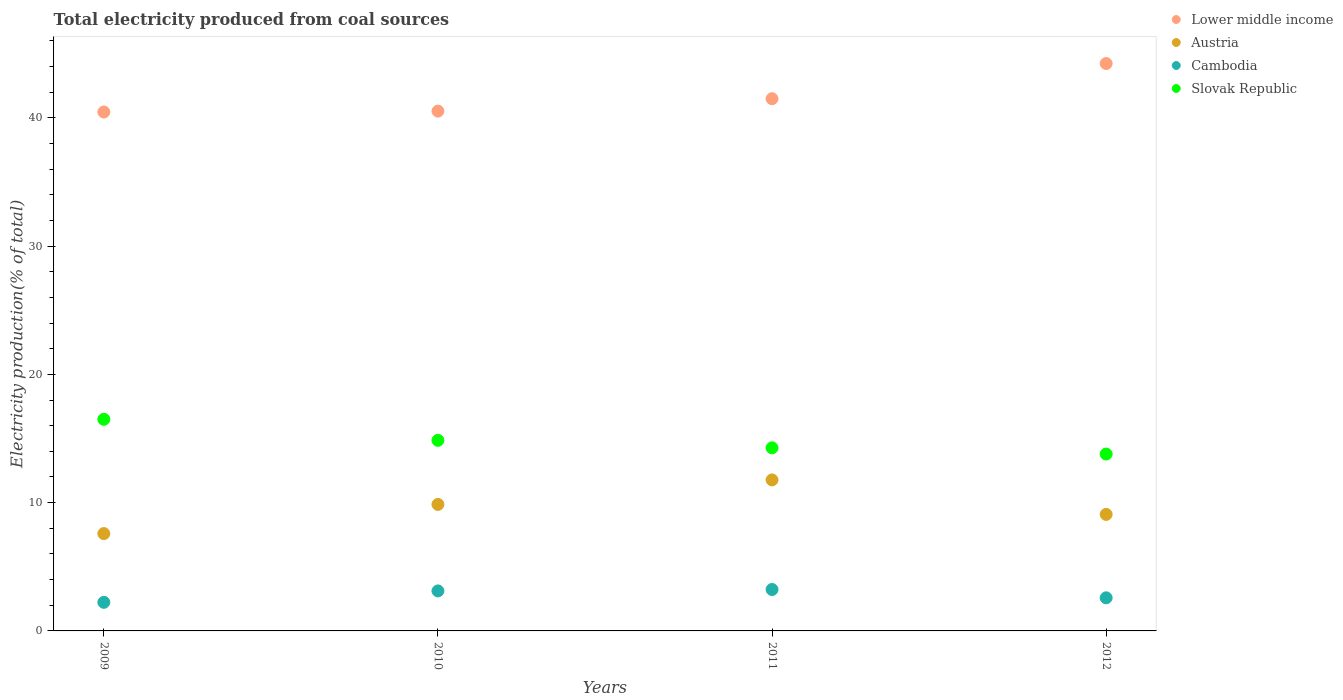How many different coloured dotlines are there?
Provide a short and direct response. 4. Is the number of dotlines equal to the number of legend labels?
Make the answer very short. Yes. What is the total electricity produced in Austria in 2011?
Your response must be concise. 11.77. Across all years, what is the maximum total electricity produced in Austria?
Keep it short and to the point. 11.77. Across all years, what is the minimum total electricity produced in Cambodia?
Provide a short and direct response. 2.23. What is the total total electricity produced in Cambodia in the graph?
Your answer should be compact. 11.16. What is the difference between the total electricity produced in Lower middle income in 2010 and that in 2012?
Offer a terse response. -3.71. What is the difference between the total electricity produced in Lower middle income in 2010 and the total electricity produced in Austria in 2012?
Offer a very short reply. 31.44. What is the average total electricity produced in Lower middle income per year?
Keep it short and to the point. 41.67. In the year 2011, what is the difference between the total electricity produced in Slovak Republic and total electricity produced in Austria?
Provide a succinct answer. 2.5. What is the ratio of the total electricity produced in Cambodia in 2010 to that in 2012?
Your answer should be compact. 1.21. Is the difference between the total electricity produced in Slovak Republic in 2009 and 2012 greater than the difference between the total electricity produced in Austria in 2009 and 2012?
Provide a succinct answer. Yes. What is the difference between the highest and the second highest total electricity produced in Austria?
Your answer should be very brief. 1.91. What is the difference between the highest and the lowest total electricity produced in Slovak Republic?
Give a very brief answer. 2.71. Is it the case that in every year, the sum of the total electricity produced in Cambodia and total electricity produced in Lower middle income  is greater than the sum of total electricity produced in Austria and total electricity produced in Slovak Republic?
Make the answer very short. Yes. Is the total electricity produced in Austria strictly greater than the total electricity produced in Cambodia over the years?
Your answer should be very brief. Yes. Is the total electricity produced in Austria strictly less than the total electricity produced in Slovak Republic over the years?
Provide a succinct answer. Yes. How many years are there in the graph?
Your response must be concise. 4. What is the difference between two consecutive major ticks on the Y-axis?
Offer a very short reply. 10. How are the legend labels stacked?
Make the answer very short. Vertical. What is the title of the graph?
Your answer should be very brief. Total electricity produced from coal sources. Does "Paraguay" appear as one of the legend labels in the graph?
Your answer should be very brief. No. What is the label or title of the X-axis?
Provide a succinct answer. Years. What is the label or title of the Y-axis?
Your answer should be very brief. Electricity production(% of total). What is the Electricity production(% of total) of Lower middle income in 2009?
Make the answer very short. 40.45. What is the Electricity production(% of total) of Austria in 2009?
Make the answer very short. 7.59. What is the Electricity production(% of total) of Cambodia in 2009?
Give a very brief answer. 2.23. What is the Electricity production(% of total) in Slovak Republic in 2009?
Your answer should be compact. 16.5. What is the Electricity production(% of total) of Lower middle income in 2010?
Provide a succinct answer. 40.52. What is the Electricity production(% of total) of Austria in 2010?
Your response must be concise. 9.86. What is the Electricity production(% of total) in Cambodia in 2010?
Offer a terse response. 3.12. What is the Electricity production(% of total) in Slovak Republic in 2010?
Provide a short and direct response. 14.86. What is the Electricity production(% of total) of Lower middle income in 2011?
Make the answer very short. 41.49. What is the Electricity production(% of total) of Austria in 2011?
Offer a very short reply. 11.77. What is the Electricity production(% of total) in Cambodia in 2011?
Ensure brevity in your answer.  3.23. What is the Electricity production(% of total) in Slovak Republic in 2011?
Provide a short and direct response. 14.27. What is the Electricity production(% of total) of Lower middle income in 2012?
Make the answer very short. 44.23. What is the Electricity production(% of total) in Austria in 2012?
Offer a very short reply. 9.08. What is the Electricity production(% of total) in Cambodia in 2012?
Offer a terse response. 2.58. What is the Electricity production(% of total) of Slovak Republic in 2012?
Your answer should be very brief. 13.79. Across all years, what is the maximum Electricity production(% of total) in Lower middle income?
Offer a very short reply. 44.23. Across all years, what is the maximum Electricity production(% of total) of Austria?
Ensure brevity in your answer.  11.77. Across all years, what is the maximum Electricity production(% of total) in Cambodia?
Your answer should be very brief. 3.23. Across all years, what is the maximum Electricity production(% of total) of Slovak Republic?
Your response must be concise. 16.5. Across all years, what is the minimum Electricity production(% of total) in Lower middle income?
Give a very brief answer. 40.45. Across all years, what is the minimum Electricity production(% of total) in Austria?
Give a very brief answer. 7.59. Across all years, what is the minimum Electricity production(% of total) in Cambodia?
Provide a succinct answer. 2.23. Across all years, what is the minimum Electricity production(% of total) of Slovak Republic?
Ensure brevity in your answer.  13.79. What is the total Electricity production(% of total) in Lower middle income in the graph?
Offer a terse response. 166.7. What is the total Electricity production(% of total) in Austria in the graph?
Make the answer very short. 38.31. What is the total Electricity production(% of total) in Cambodia in the graph?
Your answer should be very brief. 11.16. What is the total Electricity production(% of total) of Slovak Republic in the graph?
Your answer should be very brief. 59.42. What is the difference between the Electricity production(% of total) of Lower middle income in 2009 and that in 2010?
Keep it short and to the point. -0.07. What is the difference between the Electricity production(% of total) of Austria in 2009 and that in 2010?
Your answer should be very brief. -2.27. What is the difference between the Electricity production(% of total) of Cambodia in 2009 and that in 2010?
Your answer should be very brief. -0.89. What is the difference between the Electricity production(% of total) of Slovak Republic in 2009 and that in 2010?
Provide a succinct answer. 1.64. What is the difference between the Electricity production(% of total) in Lower middle income in 2009 and that in 2011?
Your response must be concise. -1.04. What is the difference between the Electricity production(% of total) in Austria in 2009 and that in 2011?
Provide a short and direct response. -4.18. What is the difference between the Electricity production(% of total) in Cambodia in 2009 and that in 2011?
Provide a short and direct response. -1. What is the difference between the Electricity production(% of total) of Slovak Republic in 2009 and that in 2011?
Provide a succinct answer. 2.22. What is the difference between the Electricity production(% of total) in Lower middle income in 2009 and that in 2012?
Your answer should be very brief. -3.78. What is the difference between the Electricity production(% of total) in Austria in 2009 and that in 2012?
Keep it short and to the point. -1.5. What is the difference between the Electricity production(% of total) in Cambodia in 2009 and that in 2012?
Your answer should be compact. -0.35. What is the difference between the Electricity production(% of total) of Slovak Republic in 2009 and that in 2012?
Your answer should be compact. 2.71. What is the difference between the Electricity production(% of total) in Lower middle income in 2010 and that in 2011?
Make the answer very short. -0.97. What is the difference between the Electricity production(% of total) of Austria in 2010 and that in 2011?
Make the answer very short. -1.91. What is the difference between the Electricity production(% of total) of Cambodia in 2010 and that in 2011?
Your answer should be very brief. -0.11. What is the difference between the Electricity production(% of total) in Slovak Republic in 2010 and that in 2011?
Provide a short and direct response. 0.58. What is the difference between the Electricity production(% of total) of Lower middle income in 2010 and that in 2012?
Provide a short and direct response. -3.71. What is the difference between the Electricity production(% of total) of Austria in 2010 and that in 2012?
Your answer should be compact. 0.78. What is the difference between the Electricity production(% of total) in Cambodia in 2010 and that in 2012?
Give a very brief answer. 0.54. What is the difference between the Electricity production(% of total) of Slovak Republic in 2010 and that in 2012?
Your response must be concise. 1.07. What is the difference between the Electricity production(% of total) of Lower middle income in 2011 and that in 2012?
Make the answer very short. -2.74. What is the difference between the Electricity production(% of total) in Austria in 2011 and that in 2012?
Provide a succinct answer. 2.69. What is the difference between the Electricity production(% of total) in Cambodia in 2011 and that in 2012?
Make the answer very short. 0.65. What is the difference between the Electricity production(% of total) in Slovak Republic in 2011 and that in 2012?
Offer a terse response. 0.49. What is the difference between the Electricity production(% of total) of Lower middle income in 2009 and the Electricity production(% of total) of Austria in 2010?
Make the answer very short. 30.59. What is the difference between the Electricity production(% of total) of Lower middle income in 2009 and the Electricity production(% of total) of Cambodia in 2010?
Make the answer very short. 37.33. What is the difference between the Electricity production(% of total) in Lower middle income in 2009 and the Electricity production(% of total) in Slovak Republic in 2010?
Your answer should be compact. 25.6. What is the difference between the Electricity production(% of total) of Austria in 2009 and the Electricity production(% of total) of Cambodia in 2010?
Give a very brief answer. 4.47. What is the difference between the Electricity production(% of total) in Austria in 2009 and the Electricity production(% of total) in Slovak Republic in 2010?
Your answer should be compact. -7.27. What is the difference between the Electricity production(% of total) of Cambodia in 2009 and the Electricity production(% of total) of Slovak Republic in 2010?
Provide a short and direct response. -12.63. What is the difference between the Electricity production(% of total) in Lower middle income in 2009 and the Electricity production(% of total) in Austria in 2011?
Make the answer very short. 28.68. What is the difference between the Electricity production(% of total) of Lower middle income in 2009 and the Electricity production(% of total) of Cambodia in 2011?
Your answer should be very brief. 37.22. What is the difference between the Electricity production(% of total) of Lower middle income in 2009 and the Electricity production(% of total) of Slovak Republic in 2011?
Ensure brevity in your answer.  26.18. What is the difference between the Electricity production(% of total) of Austria in 2009 and the Electricity production(% of total) of Cambodia in 2011?
Make the answer very short. 4.36. What is the difference between the Electricity production(% of total) in Austria in 2009 and the Electricity production(% of total) in Slovak Republic in 2011?
Give a very brief answer. -6.69. What is the difference between the Electricity production(% of total) in Cambodia in 2009 and the Electricity production(% of total) in Slovak Republic in 2011?
Keep it short and to the point. -12.05. What is the difference between the Electricity production(% of total) of Lower middle income in 2009 and the Electricity production(% of total) of Austria in 2012?
Your answer should be very brief. 31.37. What is the difference between the Electricity production(% of total) of Lower middle income in 2009 and the Electricity production(% of total) of Cambodia in 2012?
Your answer should be very brief. 37.87. What is the difference between the Electricity production(% of total) of Lower middle income in 2009 and the Electricity production(% of total) of Slovak Republic in 2012?
Your answer should be compact. 26.66. What is the difference between the Electricity production(% of total) of Austria in 2009 and the Electricity production(% of total) of Cambodia in 2012?
Keep it short and to the point. 5.01. What is the difference between the Electricity production(% of total) of Austria in 2009 and the Electricity production(% of total) of Slovak Republic in 2012?
Make the answer very short. -6.2. What is the difference between the Electricity production(% of total) in Cambodia in 2009 and the Electricity production(% of total) in Slovak Republic in 2012?
Your answer should be compact. -11.56. What is the difference between the Electricity production(% of total) of Lower middle income in 2010 and the Electricity production(% of total) of Austria in 2011?
Give a very brief answer. 28.75. What is the difference between the Electricity production(% of total) of Lower middle income in 2010 and the Electricity production(% of total) of Cambodia in 2011?
Provide a succinct answer. 37.29. What is the difference between the Electricity production(% of total) in Lower middle income in 2010 and the Electricity production(% of total) in Slovak Republic in 2011?
Your answer should be compact. 26.25. What is the difference between the Electricity production(% of total) in Austria in 2010 and the Electricity production(% of total) in Cambodia in 2011?
Your answer should be very brief. 6.63. What is the difference between the Electricity production(% of total) in Austria in 2010 and the Electricity production(% of total) in Slovak Republic in 2011?
Offer a very short reply. -4.41. What is the difference between the Electricity production(% of total) in Cambodia in 2010 and the Electricity production(% of total) in Slovak Republic in 2011?
Make the answer very short. -11.16. What is the difference between the Electricity production(% of total) of Lower middle income in 2010 and the Electricity production(% of total) of Austria in 2012?
Give a very brief answer. 31.44. What is the difference between the Electricity production(% of total) in Lower middle income in 2010 and the Electricity production(% of total) in Cambodia in 2012?
Your answer should be compact. 37.94. What is the difference between the Electricity production(% of total) of Lower middle income in 2010 and the Electricity production(% of total) of Slovak Republic in 2012?
Make the answer very short. 26.73. What is the difference between the Electricity production(% of total) of Austria in 2010 and the Electricity production(% of total) of Cambodia in 2012?
Provide a short and direct response. 7.28. What is the difference between the Electricity production(% of total) of Austria in 2010 and the Electricity production(% of total) of Slovak Republic in 2012?
Your answer should be very brief. -3.93. What is the difference between the Electricity production(% of total) of Cambodia in 2010 and the Electricity production(% of total) of Slovak Republic in 2012?
Provide a short and direct response. -10.67. What is the difference between the Electricity production(% of total) in Lower middle income in 2011 and the Electricity production(% of total) in Austria in 2012?
Offer a very short reply. 32.41. What is the difference between the Electricity production(% of total) of Lower middle income in 2011 and the Electricity production(% of total) of Cambodia in 2012?
Offer a terse response. 38.91. What is the difference between the Electricity production(% of total) in Lower middle income in 2011 and the Electricity production(% of total) in Slovak Republic in 2012?
Offer a terse response. 27.7. What is the difference between the Electricity production(% of total) in Austria in 2011 and the Electricity production(% of total) in Cambodia in 2012?
Keep it short and to the point. 9.19. What is the difference between the Electricity production(% of total) in Austria in 2011 and the Electricity production(% of total) in Slovak Republic in 2012?
Offer a terse response. -2.02. What is the difference between the Electricity production(% of total) of Cambodia in 2011 and the Electricity production(% of total) of Slovak Republic in 2012?
Ensure brevity in your answer.  -10.56. What is the average Electricity production(% of total) of Lower middle income per year?
Make the answer very short. 41.67. What is the average Electricity production(% of total) of Austria per year?
Your answer should be very brief. 9.58. What is the average Electricity production(% of total) in Cambodia per year?
Offer a very short reply. 2.79. What is the average Electricity production(% of total) of Slovak Republic per year?
Provide a short and direct response. 14.85. In the year 2009, what is the difference between the Electricity production(% of total) in Lower middle income and Electricity production(% of total) in Austria?
Offer a very short reply. 32.87. In the year 2009, what is the difference between the Electricity production(% of total) in Lower middle income and Electricity production(% of total) in Cambodia?
Your answer should be very brief. 38.22. In the year 2009, what is the difference between the Electricity production(% of total) of Lower middle income and Electricity production(% of total) of Slovak Republic?
Provide a short and direct response. 23.96. In the year 2009, what is the difference between the Electricity production(% of total) of Austria and Electricity production(% of total) of Cambodia?
Keep it short and to the point. 5.36. In the year 2009, what is the difference between the Electricity production(% of total) of Austria and Electricity production(% of total) of Slovak Republic?
Your answer should be very brief. -8.91. In the year 2009, what is the difference between the Electricity production(% of total) in Cambodia and Electricity production(% of total) in Slovak Republic?
Provide a short and direct response. -14.27. In the year 2010, what is the difference between the Electricity production(% of total) in Lower middle income and Electricity production(% of total) in Austria?
Ensure brevity in your answer.  30.66. In the year 2010, what is the difference between the Electricity production(% of total) of Lower middle income and Electricity production(% of total) of Cambodia?
Keep it short and to the point. 37.4. In the year 2010, what is the difference between the Electricity production(% of total) in Lower middle income and Electricity production(% of total) in Slovak Republic?
Offer a terse response. 25.67. In the year 2010, what is the difference between the Electricity production(% of total) in Austria and Electricity production(% of total) in Cambodia?
Provide a succinct answer. 6.74. In the year 2010, what is the difference between the Electricity production(% of total) in Austria and Electricity production(% of total) in Slovak Republic?
Your answer should be very brief. -4.99. In the year 2010, what is the difference between the Electricity production(% of total) of Cambodia and Electricity production(% of total) of Slovak Republic?
Provide a succinct answer. -11.74. In the year 2011, what is the difference between the Electricity production(% of total) of Lower middle income and Electricity production(% of total) of Austria?
Give a very brief answer. 29.72. In the year 2011, what is the difference between the Electricity production(% of total) of Lower middle income and Electricity production(% of total) of Cambodia?
Ensure brevity in your answer.  38.26. In the year 2011, what is the difference between the Electricity production(% of total) of Lower middle income and Electricity production(% of total) of Slovak Republic?
Offer a very short reply. 27.21. In the year 2011, what is the difference between the Electricity production(% of total) in Austria and Electricity production(% of total) in Cambodia?
Offer a very short reply. 8.54. In the year 2011, what is the difference between the Electricity production(% of total) in Austria and Electricity production(% of total) in Slovak Republic?
Your response must be concise. -2.5. In the year 2011, what is the difference between the Electricity production(% of total) of Cambodia and Electricity production(% of total) of Slovak Republic?
Your answer should be very brief. -11.05. In the year 2012, what is the difference between the Electricity production(% of total) of Lower middle income and Electricity production(% of total) of Austria?
Offer a very short reply. 35.15. In the year 2012, what is the difference between the Electricity production(% of total) in Lower middle income and Electricity production(% of total) in Cambodia?
Provide a succinct answer. 41.65. In the year 2012, what is the difference between the Electricity production(% of total) in Lower middle income and Electricity production(% of total) in Slovak Republic?
Offer a very short reply. 30.45. In the year 2012, what is the difference between the Electricity production(% of total) of Austria and Electricity production(% of total) of Cambodia?
Give a very brief answer. 6.5. In the year 2012, what is the difference between the Electricity production(% of total) of Austria and Electricity production(% of total) of Slovak Republic?
Keep it short and to the point. -4.7. In the year 2012, what is the difference between the Electricity production(% of total) in Cambodia and Electricity production(% of total) in Slovak Republic?
Ensure brevity in your answer.  -11.21. What is the ratio of the Electricity production(% of total) in Lower middle income in 2009 to that in 2010?
Your answer should be very brief. 1. What is the ratio of the Electricity production(% of total) of Austria in 2009 to that in 2010?
Your answer should be very brief. 0.77. What is the ratio of the Electricity production(% of total) in Cambodia in 2009 to that in 2010?
Offer a very short reply. 0.71. What is the ratio of the Electricity production(% of total) in Slovak Republic in 2009 to that in 2010?
Ensure brevity in your answer.  1.11. What is the ratio of the Electricity production(% of total) of Lower middle income in 2009 to that in 2011?
Offer a very short reply. 0.97. What is the ratio of the Electricity production(% of total) in Austria in 2009 to that in 2011?
Ensure brevity in your answer.  0.64. What is the ratio of the Electricity production(% of total) of Cambodia in 2009 to that in 2011?
Your answer should be very brief. 0.69. What is the ratio of the Electricity production(% of total) in Slovak Republic in 2009 to that in 2011?
Your response must be concise. 1.16. What is the ratio of the Electricity production(% of total) in Lower middle income in 2009 to that in 2012?
Offer a terse response. 0.91. What is the ratio of the Electricity production(% of total) of Austria in 2009 to that in 2012?
Offer a terse response. 0.84. What is the ratio of the Electricity production(% of total) of Cambodia in 2009 to that in 2012?
Give a very brief answer. 0.86. What is the ratio of the Electricity production(% of total) in Slovak Republic in 2009 to that in 2012?
Ensure brevity in your answer.  1.2. What is the ratio of the Electricity production(% of total) of Lower middle income in 2010 to that in 2011?
Give a very brief answer. 0.98. What is the ratio of the Electricity production(% of total) in Austria in 2010 to that in 2011?
Your answer should be very brief. 0.84. What is the ratio of the Electricity production(% of total) in Cambodia in 2010 to that in 2011?
Provide a short and direct response. 0.97. What is the ratio of the Electricity production(% of total) of Slovak Republic in 2010 to that in 2011?
Your answer should be compact. 1.04. What is the ratio of the Electricity production(% of total) in Lower middle income in 2010 to that in 2012?
Offer a terse response. 0.92. What is the ratio of the Electricity production(% of total) in Austria in 2010 to that in 2012?
Your answer should be compact. 1.09. What is the ratio of the Electricity production(% of total) in Cambodia in 2010 to that in 2012?
Give a very brief answer. 1.21. What is the ratio of the Electricity production(% of total) in Slovak Republic in 2010 to that in 2012?
Make the answer very short. 1.08. What is the ratio of the Electricity production(% of total) of Lower middle income in 2011 to that in 2012?
Provide a succinct answer. 0.94. What is the ratio of the Electricity production(% of total) of Austria in 2011 to that in 2012?
Offer a terse response. 1.3. What is the ratio of the Electricity production(% of total) in Cambodia in 2011 to that in 2012?
Offer a terse response. 1.25. What is the ratio of the Electricity production(% of total) of Slovak Republic in 2011 to that in 2012?
Ensure brevity in your answer.  1.04. What is the difference between the highest and the second highest Electricity production(% of total) of Lower middle income?
Offer a terse response. 2.74. What is the difference between the highest and the second highest Electricity production(% of total) of Austria?
Offer a very short reply. 1.91. What is the difference between the highest and the second highest Electricity production(% of total) of Cambodia?
Your answer should be very brief. 0.11. What is the difference between the highest and the second highest Electricity production(% of total) of Slovak Republic?
Your answer should be very brief. 1.64. What is the difference between the highest and the lowest Electricity production(% of total) of Lower middle income?
Give a very brief answer. 3.78. What is the difference between the highest and the lowest Electricity production(% of total) in Austria?
Keep it short and to the point. 4.18. What is the difference between the highest and the lowest Electricity production(% of total) of Cambodia?
Offer a terse response. 1. What is the difference between the highest and the lowest Electricity production(% of total) in Slovak Republic?
Give a very brief answer. 2.71. 